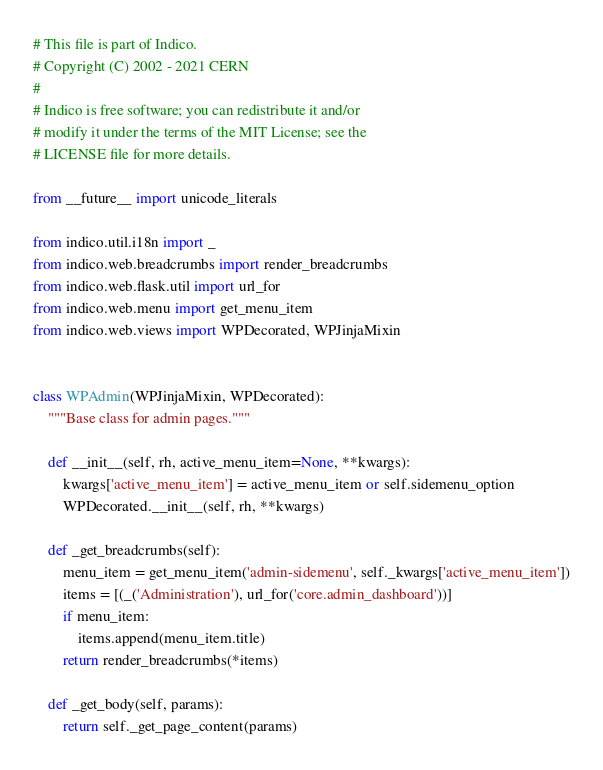Convert code to text. <code><loc_0><loc_0><loc_500><loc_500><_Python_># This file is part of Indico.
# Copyright (C) 2002 - 2021 CERN
#
# Indico is free software; you can redistribute it and/or
# modify it under the terms of the MIT License; see the
# LICENSE file for more details.

from __future__ import unicode_literals

from indico.util.i18n import _
from indico.web.breadcrumbs import render_breadcrumbs
from indico.web.flask.util import url_for
from indico.web.menu import get_menu_item
from indico.web.views import WPDecorated, WPJinjaMixin


class WPAdmin(WPJinjaMixin, WPDecorated):
    """Base class for admin pages."""

    def __init__(self, rh, active_menu_item=None, **kwargs):
        kwargs['active_menu_item'] = active_menu_item or self.sidemenu_option
        WPDecorated.__init__(self, rh, **kwargs)

    def _get_breadcrumbs(self):
        menu_item = get_menu_item('admin-sidemenu', self._kwargs['active_menu_item'])
        items = [(_('Administration'), url_for('core.admin_dashboard'))]
        if menu_item:
            items.append(menu_item.title)
        return render_breadcrumbs(*items)

    def _get_body(self, params):
        return self._get_page_content(params)
</code> 